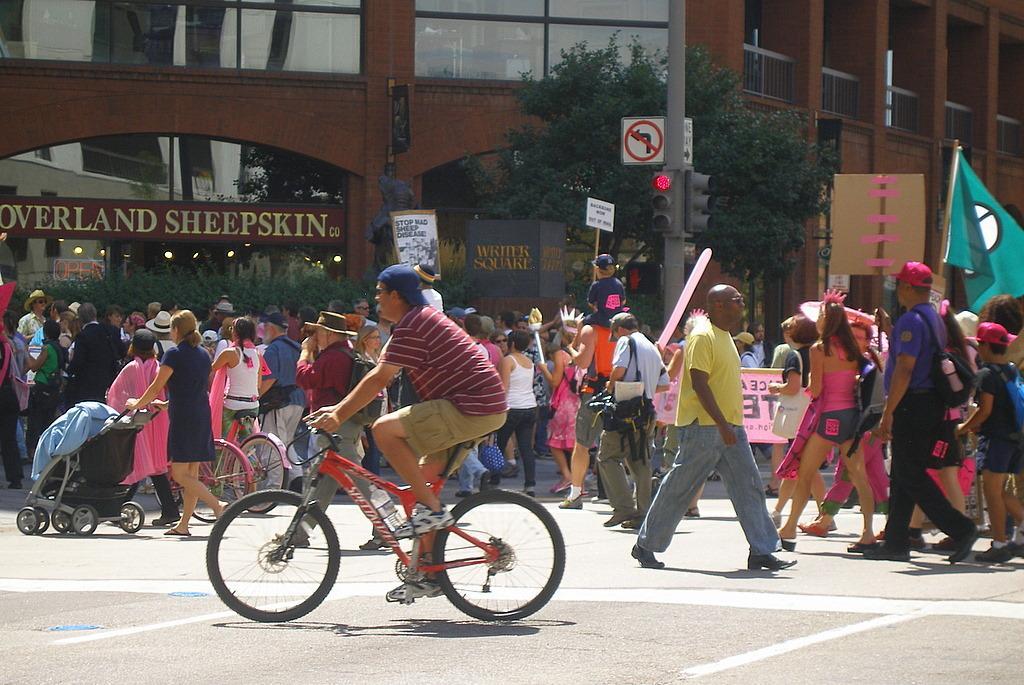Can you describe this image briefly? In this image there is a person in the center riding a bicycle on a road. He is wearing a red t shirt and cream shorts. In the background there are group of people, signal light, building, flag and board. 